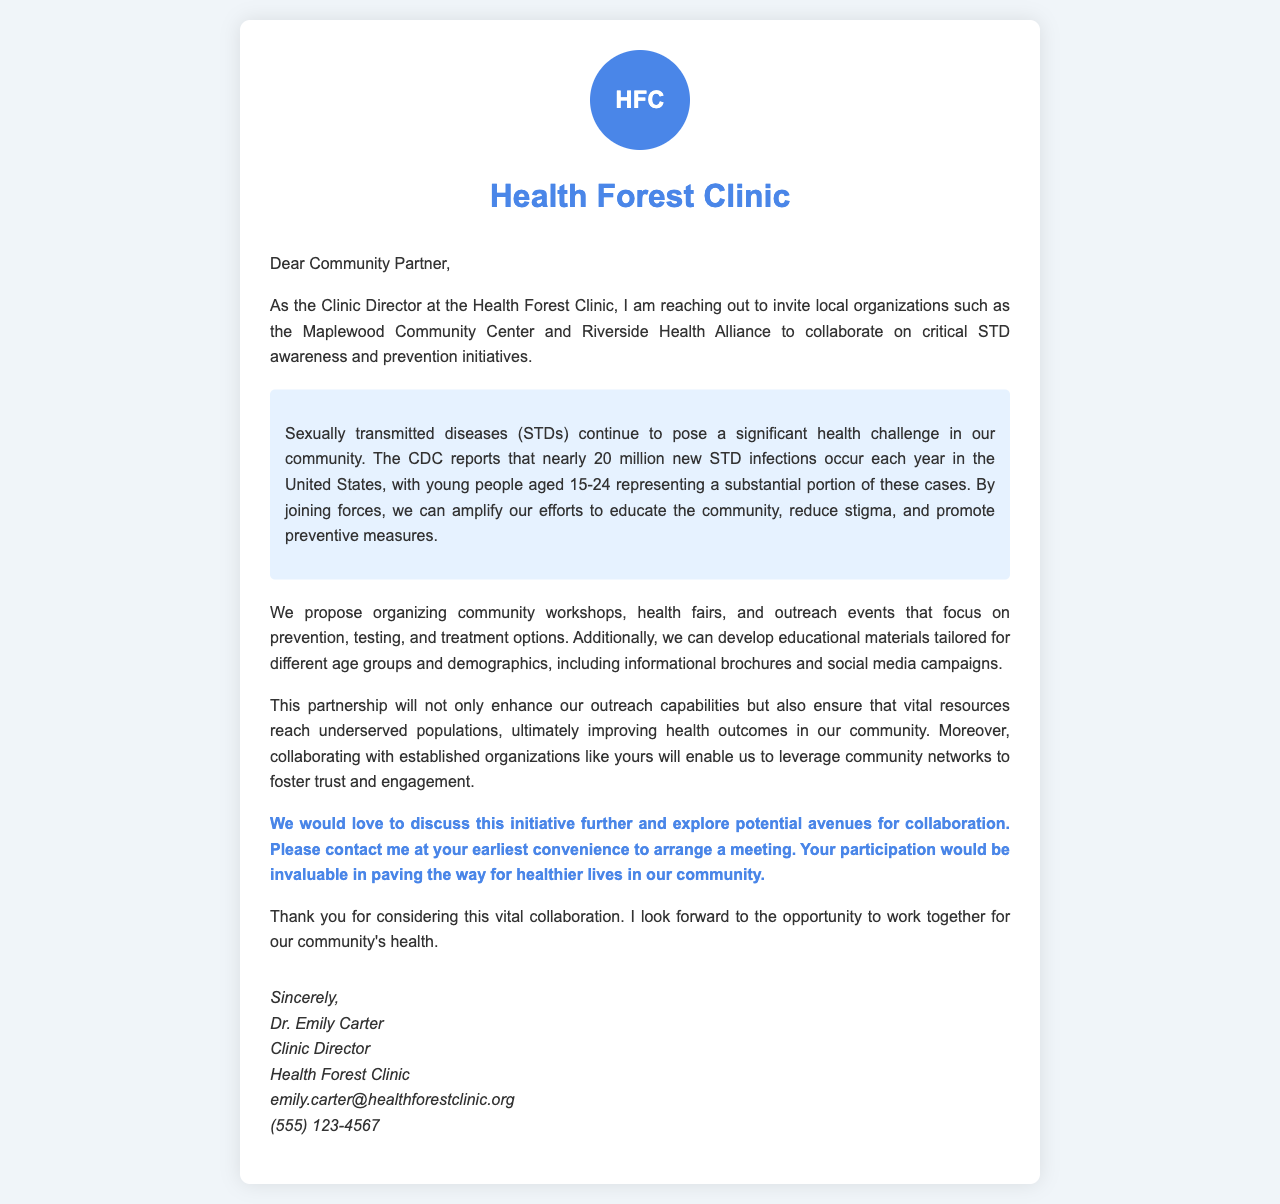What is the name of the clinic? The name of the clinic is mentioned at the top of the document.
Answer: Health Forest Clinic Who is the Clinic Director? The Clinic Director's name is provided in the signature section.
Answer: Dr. Emily Carter What significant health challenge is mentioned? The document describes a specific health challenge in the community.
Answer: STDs What age group accounts for a substantial portion of new STD infections? The age group is specified in the document with particular emphasis.
Answer: 15-24 What is proposed to improve STD awareness? The document lists specific activities that are proposed to enhance awareness.
Answer: Community workshops What is the call to action in the document? The document includes a clear invitation for further engagement.
Answer: Contact me at your earliest convenience What organization's participation is considered invaluable? The document implies the importance of collaboration with local organizations.
Answer: Your organization How many new STD infections occur each year in the US? The number of new infections is provided in the letter, highlighting the scope of the issue.
Answer: Nearly 20 million 